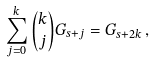Convert formula to latex. <formula><loc_0><loc_0><loc_500><loc_500>\sum _ { j = 0 } ^ { k } { \binom { k } { j } G _ { s + j } } = G _ { s + 2 k } \, ,</formula> 